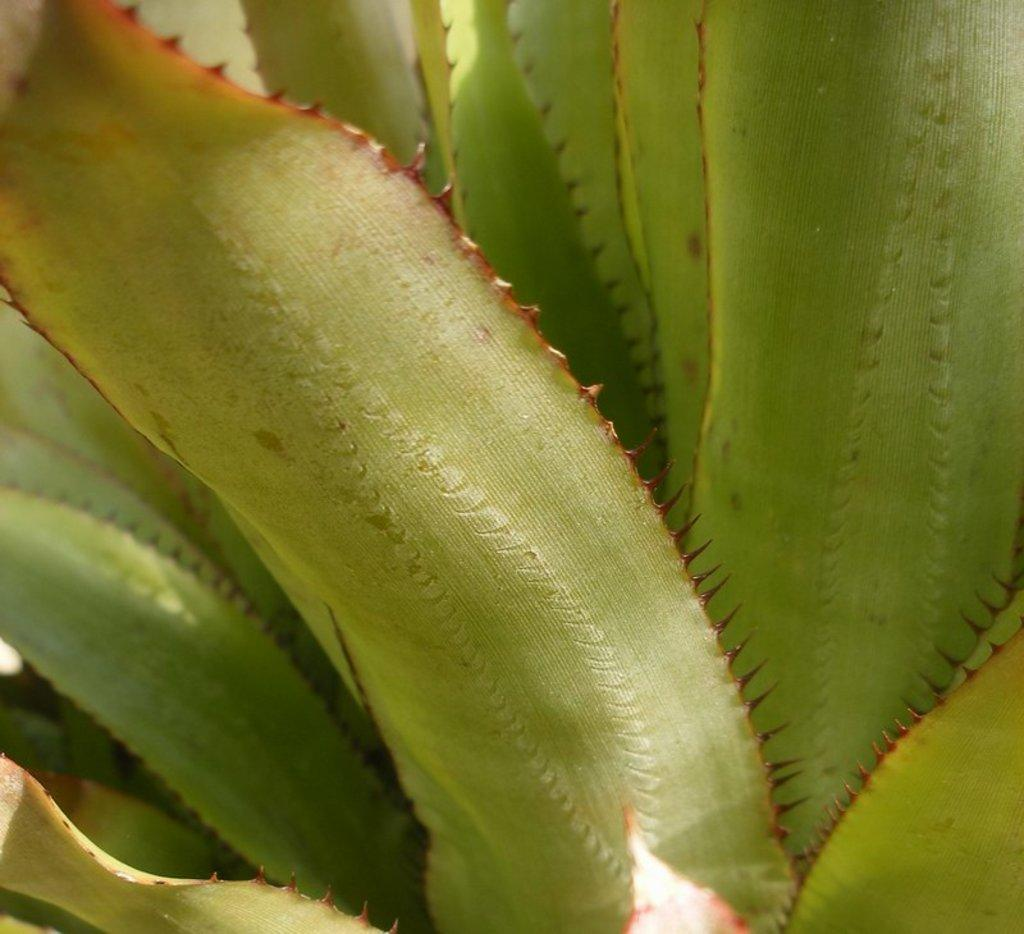What type of plant material is present in the image? There are leaves in the image. Can you describe any specific features of the leaves? The leaves have thorns on their sides. What type of glue is being used by the committee in the image? There is no committee or glue present in the image; it only features leaves with thorns. 